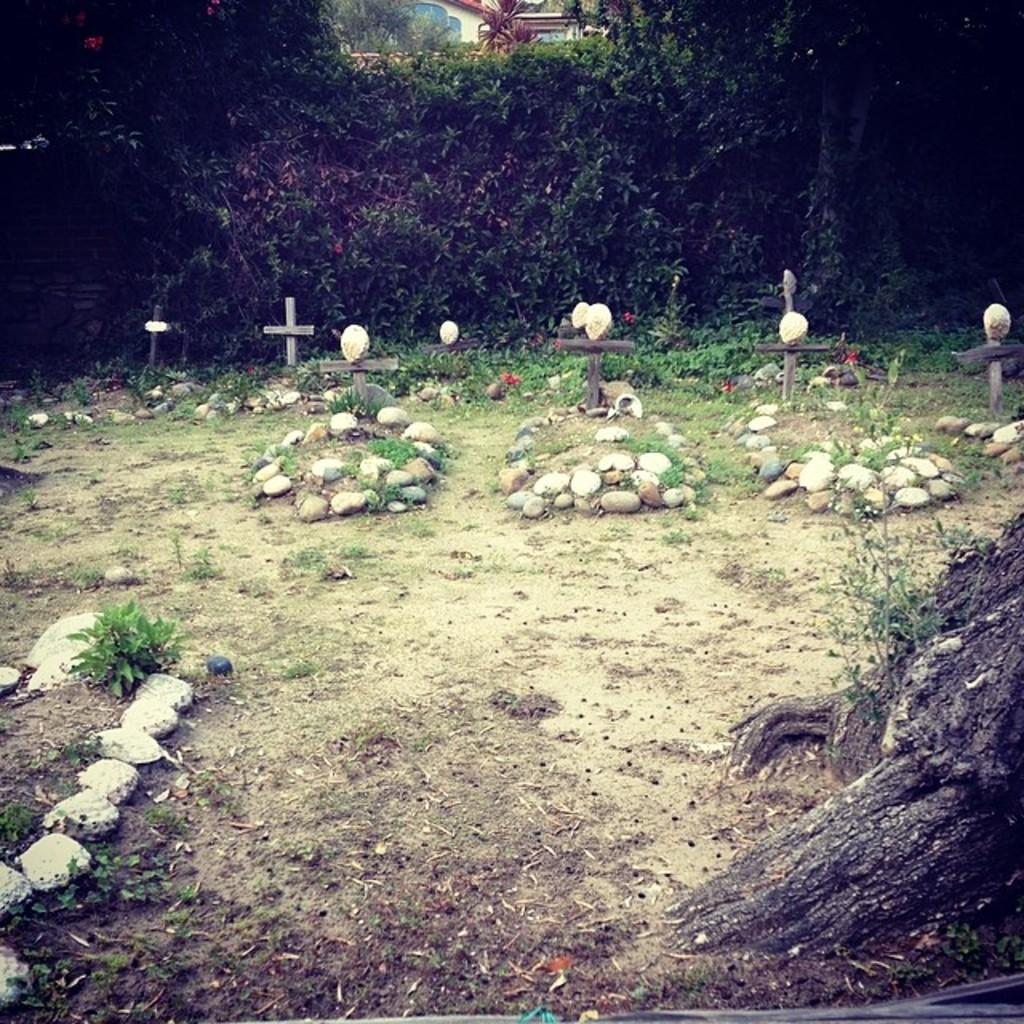What type of natural elements can be seen in the image? There are stones, grass, and trees in the image. What type of structure is visible in the background of the image? There is a building in the background of the image. What color is the flower that is growing near the building in the image? There is no flower present in the image; it only features stones, grass, trees, and a building. 